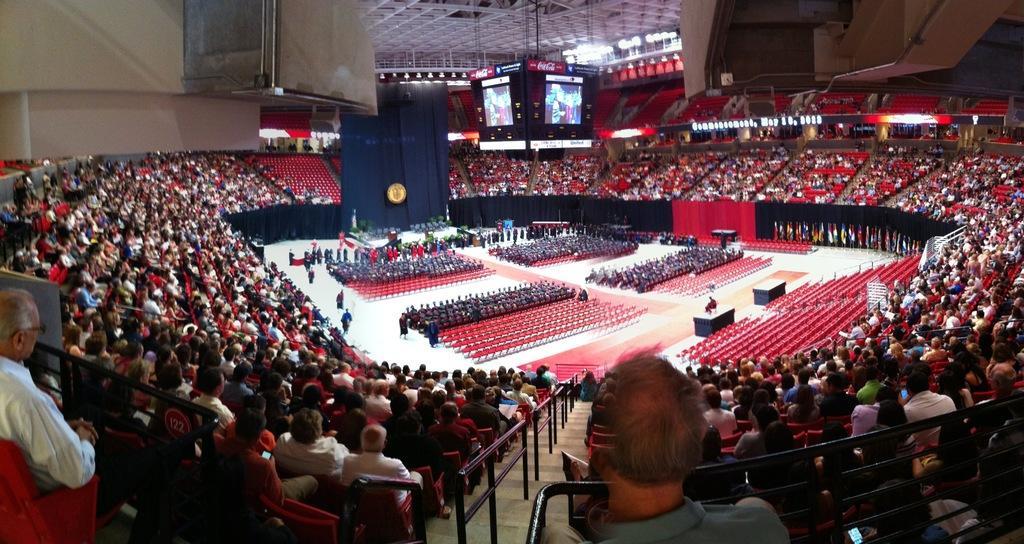In one or two sentences, can you explain what this image depicts? This picture looks like an auditorium, in this image we can see a few people, among them some are sitting on the chairs and some are standing, there are tables, flags, screens, lights and some other objects. 